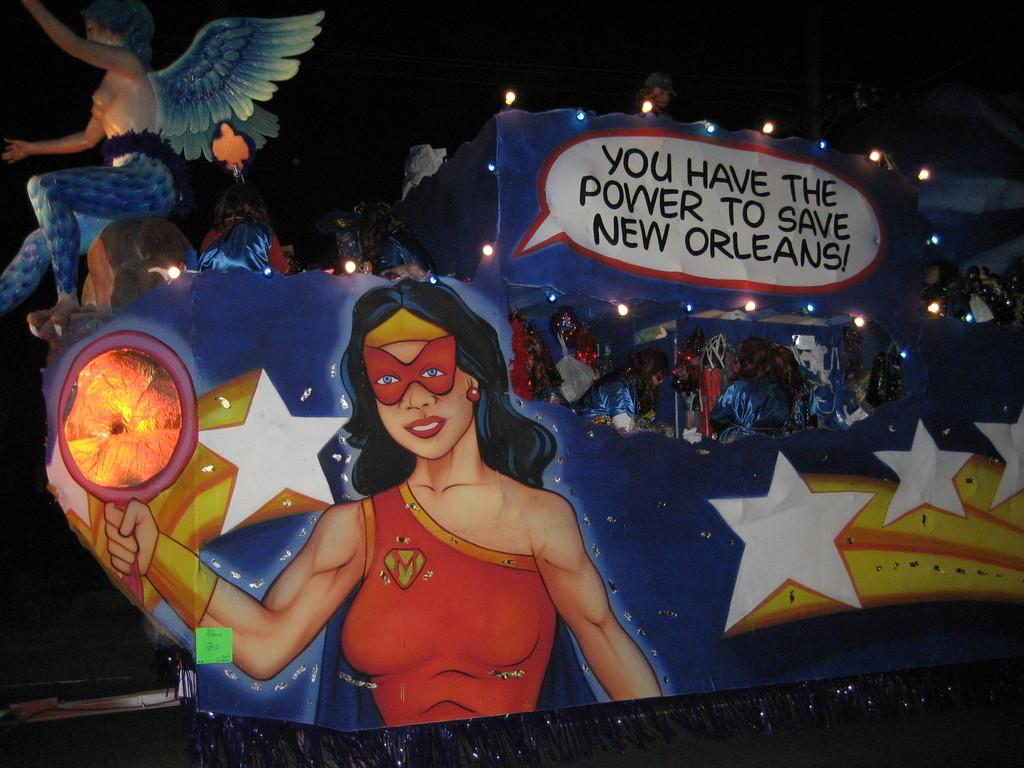What type of artwork is featured on a board in the image? There is a painting on a board in the image. What other type of artwork can be seen in the image? There is a sculpture in the image. Can you describe the person in the image? There is a person in the image. What architectural feature is present in the image? There is a pole in the image. What utilities are visible in the image? There are wires and lights in the image. How would you describe the lighting in the image? The background of the image is dark. What is the title of the painting on the board in the image? There is no information provided about the title of the painting in the image. Can you see a ghost in the image? There is no mention of a ghost in the image, and it is not present. 